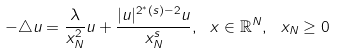Convert formula to latex. <formula><loc_0><loc_0><loc_500><loc_500>- \triangle u = \frac { \lambda } { x ^ { 2 } _ { N } } u + \frac { | u | ^ { 2 ^ { * } ( s ) - 2 } u } { x ^ { s } _ { N } } , \ x \in \mathbb { R } ^ { N } , \ x _ { N } \geq 0</formula> 